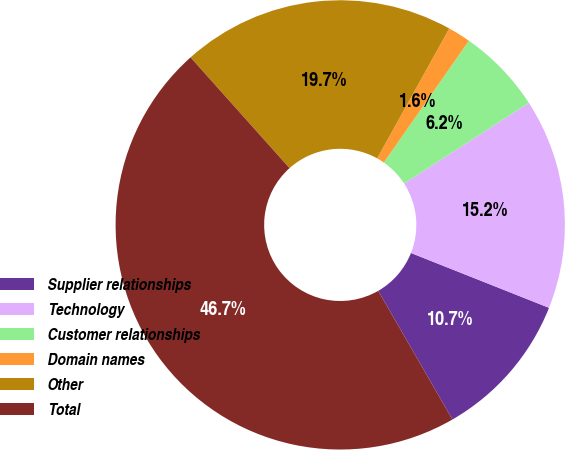<chart> <loc_0><loc_0><loc_500><loc_500><pie_chart><fcel>Supplier relationships<fcel>Technology<fcel>Customer relationships<fcel>Domain names<fcel>Other<fcel>Total<nl><fcel>10.66%<fcel>15.16%<fcel>6.15%<fcel>1.64%<fcel>19.67%<fcel>46.71%<nl></chart> 